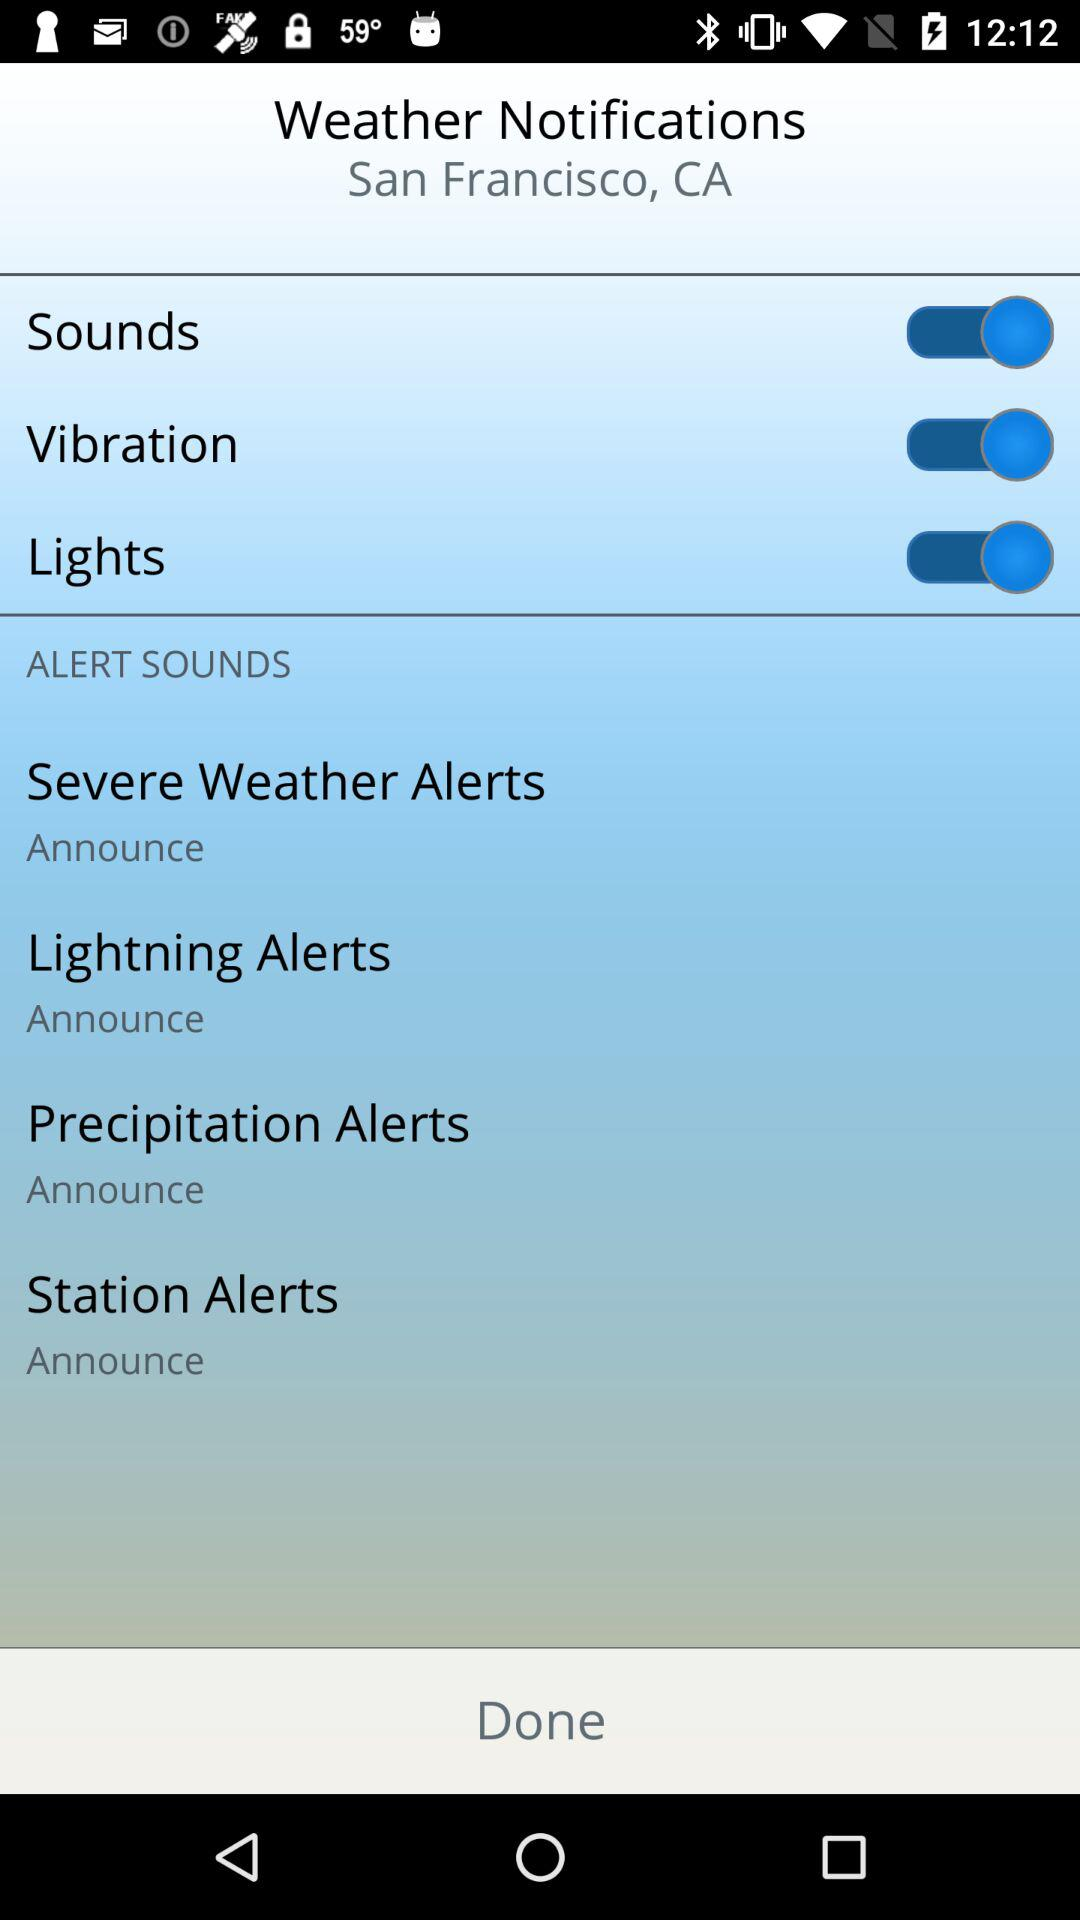How many alert sounds are available?
Answer the question using a single word or phrase. 4 